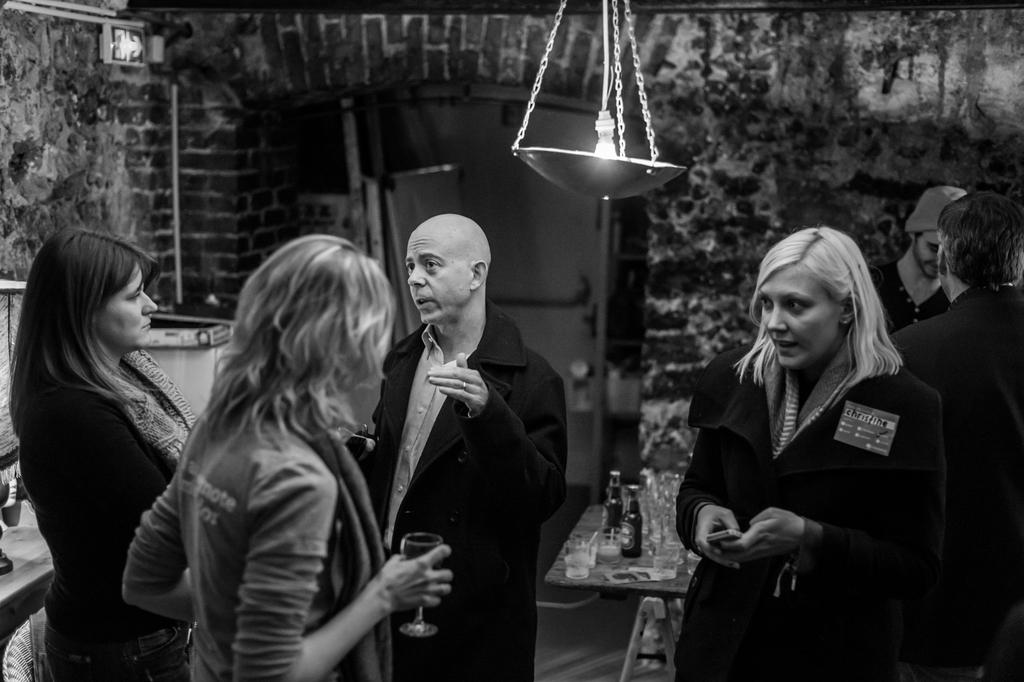What is the color scheme of the image? The image is black and white. Can you describe the people in the image? There are people in the image, but their specific features or actions are not described. What type of structures are present in the image? There are walls, a signboard, a table, a door, and chains visible in the image. What is the source of illumination in the image? There is a light in the image. What objects are placed above the table? There are glasses and bottles above the table. What other "things" can be seen in the image that are not explicitly described? The image contains various "things" that are not explicitly described. What type of business is being conducted in the image? There is no indication of a business being conducted in the image. Can you see a cart in the image? There is no cart present in the image. What rule is being enforced by the chains in the image? The chains in the image do not enforce any rules; they are simply present as part of the scene. 